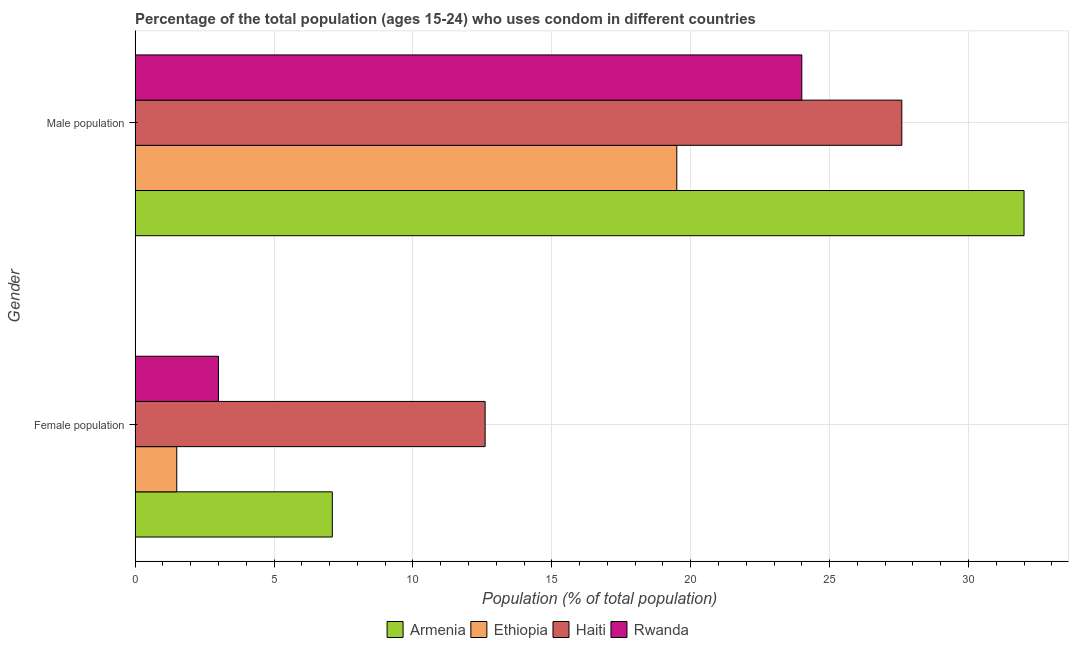How many different coloured bars are there?
Your answer should be compact. 4. How many groups of bars are there?
Ensure brevity in your answer.  2. Are the number of bars per tick equal to the number of legend labels?
Provide a short and direct response. Yes. How many bars are there on the 1st tick from the top?
Ensure brevity in your answer.  4. What is the label of the 2nd group of bars from the top?
Give a very brief answer. Female population. What is the male population in Haiti?
Offer a very short reply. 27.6. Across all countries, what is the maximum male population?
Provide a succinct answer. 32. In which country was the male population maximum?
Your answer should be very brief. Armenia. In which country was the female population minimum?
Keep it short and to the point. Ethiopia. What is the total female population in the graph?
Your answer should be very brief. 24.2. What is the difference between the male population in Ethiopia and that in Rwanda?
Ensure brevity in your answer.  -4.5. What is the difference between the female population in Haiti and the male population in Armenia?
Provide a succinct answer. -19.4. What is the average male population per country?
Give a very brief answer. 25.77. What is the difference between the female population and male population in Rwanda?
Keep it short and to the point. -21. What is the ratio of the female population in Rwanda to that in Haiti?
Your answer should be very brief. 0.24. Is the male population in Armenia less than that in Rwanda?
Give a very brief answer. No. In how many countries, is the female population greater than the average female population taken over all countries?
Provide a short and direct response. 2. What does the 3rd bar from the top in Female population represents?
Give a very brief answer. Ethiopia. What does the 3rd bar from the bottom in Female population represents?
Give a very brief answer. Haiti. Are all the bars in the graph horizontal?
Offer a terse response. Yes. How many countries are there in the graph?
Provide a short and direct response. 4. Does the graph contain any zero values?
Your answer should be very brief. No. Does the graph contain grids?
Keep it short and to the point. Yes. How many legend labels are there?
Offer a terse response. 4. How are the legend labels stacked?
Your answer should be very brief. Horizontal. What is the title of the graph?
Provide a short and direct response. Percentage of the total population (ages 15-24) who uses condom in different countries. Does "Bolivia" appear as one of the legend labels in the graph?
Provide a short and direct response. No. What is the label or title of the X-axis?
Provide a short and direct response. Population (% of total population) . What is the Population (% of total population)  of Armenia in Male population?
Keep it short and to the point. 32. What is the Population (% of total population)  of Ethiopia in Male population?
Your answer should be very brief. 19.5. What is the Population (% of total population)  of Haiti in Male population?
Offer a very short reply. 27.6. What is the Population (% of total population)  in Rwanda in Male population?
Make the answer very short. 24. Across all Gender, what is the maximum Population (% of total population)  of Haiti?
Offer a very short reply. 27.6. Across all Gender, what is the minimum Population (% of total population)  in Armenia?
Keep it short and to the point. 7.1. Across all Gender, what is the minimum Population (% of total population)  in Ethiopia?
Provide a succinct answer. 1.5. Across all Gender, what is the minimum Population (% of total population)  in Haiti?
Keep it short and to the point. 12.6. Across all Gender, what is the minimum Population (% of total population)  in Rwanda?
Provide a short and direct response. 3. What is the total Population (% of total population)  of Armenia in the graph?
Your response must be concise. 39.1. What is the total Population (% of total population)  of Ethiopia in the graph?
Your answer should be very brief. 21. What is the total Population (% of total population)  in Haiti in the graph?
Offer a terse response. 40.2. What is the difference between the Population (% of total population)  of Armenia in Female population and that in Male population?
Provide a short and direct response. -24.9. What is the difference between the Population (% of total population)  in Haiti in Female population and that in Male population?
Provide a short and direct response. -15. What is the difference between the Population (% of total population)  in Rwanda in Female population and that in Male population?
Offer a terse response. -21. What is the difference between the Population (% of total population)  of Armenia in Female population and the Population (% of total population)  of Ethiopia in Male population?
Provide a succinct answer. -12.4. What is the difference between the Population (% of total population)  in Armenia in Female population and the Population (% of total population)  in Haiti in Male population?
Keep it short and to the point. -20.5. What is the difference between the Population (% of total population)  of Armenia in Female population and the Population (% of total population)  of Rwanda in Male population?
Make the answer very short. -16.9. What is the difference between the Population (% of total population)  in Ethiopia in Female population and the Population (% of total population)  in Haiti in Male population?
Make the answer very short. -26.1. What is the difference between the Population (% of total population)  in Ethiopia in Female population and the Population (% of total population)  in Rwanda in Male population?
Offer a very short reply. -22.5. What is the average Population (% of total population)  of Armenia per Gender?
Make the answer very short. 19.55. What is the average Population (% of total population)  in Ethiopia per Gender?
Keep it short and to the point. 10.5. What is the average Population (% of total population)  of Haiti per Gender?
Ensure brevity in your answer.  20.1. What is the average Population (% of total population)  in Rwanda per Gender?
Give a very brief answer. 13.5. What is the difference between the Population (% of total population)  in Armenia and Population (% of total population)  in Ethiopia in Female population?
Ensure brevity in your answer.  5.6. What is the difference between the Population (% of total population)  in Armenia and Population (% of total population)  in Haiti in Female population?
Your answer should be compact. -5.5. What is the difference between the Population (% of total population)  in Armenia and Population (% of total population)  in Rwanda in Male population?
Your response must be concise. 8. What is the difference between the Population (% of total population)  in Ethiopia and Population (% of total population)  in Haiti in Male population?
Offer a very short reply. -8.1. What is the ratio of the Population (% of total population)  in Armenia in Female population to that in Male population?
Ensure brevity in your answer.  0.22. What is the ratio of the Population (% of total population)  of Ethiopia in Female population to that in Male population?
Keep it short and to the point. 0.08. What is the ratio of the Population (% of total population)  of Haiti in Female population to that in Male population?
Make the answer very short. 0.46. What is the ratio of the Population (% of total population)  of Rwanda in Female population to that in Male population?
Provide a short and direct response. 0.12. What is the difference between the highest and the second highest Population (% of total population)  in Armenia?
Give a very brief answer. 24.9. What is the difference between the highest and the second highest Population (% of total population)  of Haiti?
Make the answer very short. 15. What is the difference between the highest and the lowest Population (% of total population)  in Armenia?
Offer a very short reply. 24.9. What is the difference between the highest and the lowest Population (% of total population)  in Ethiopia?
Offer a very short reply. 18. 